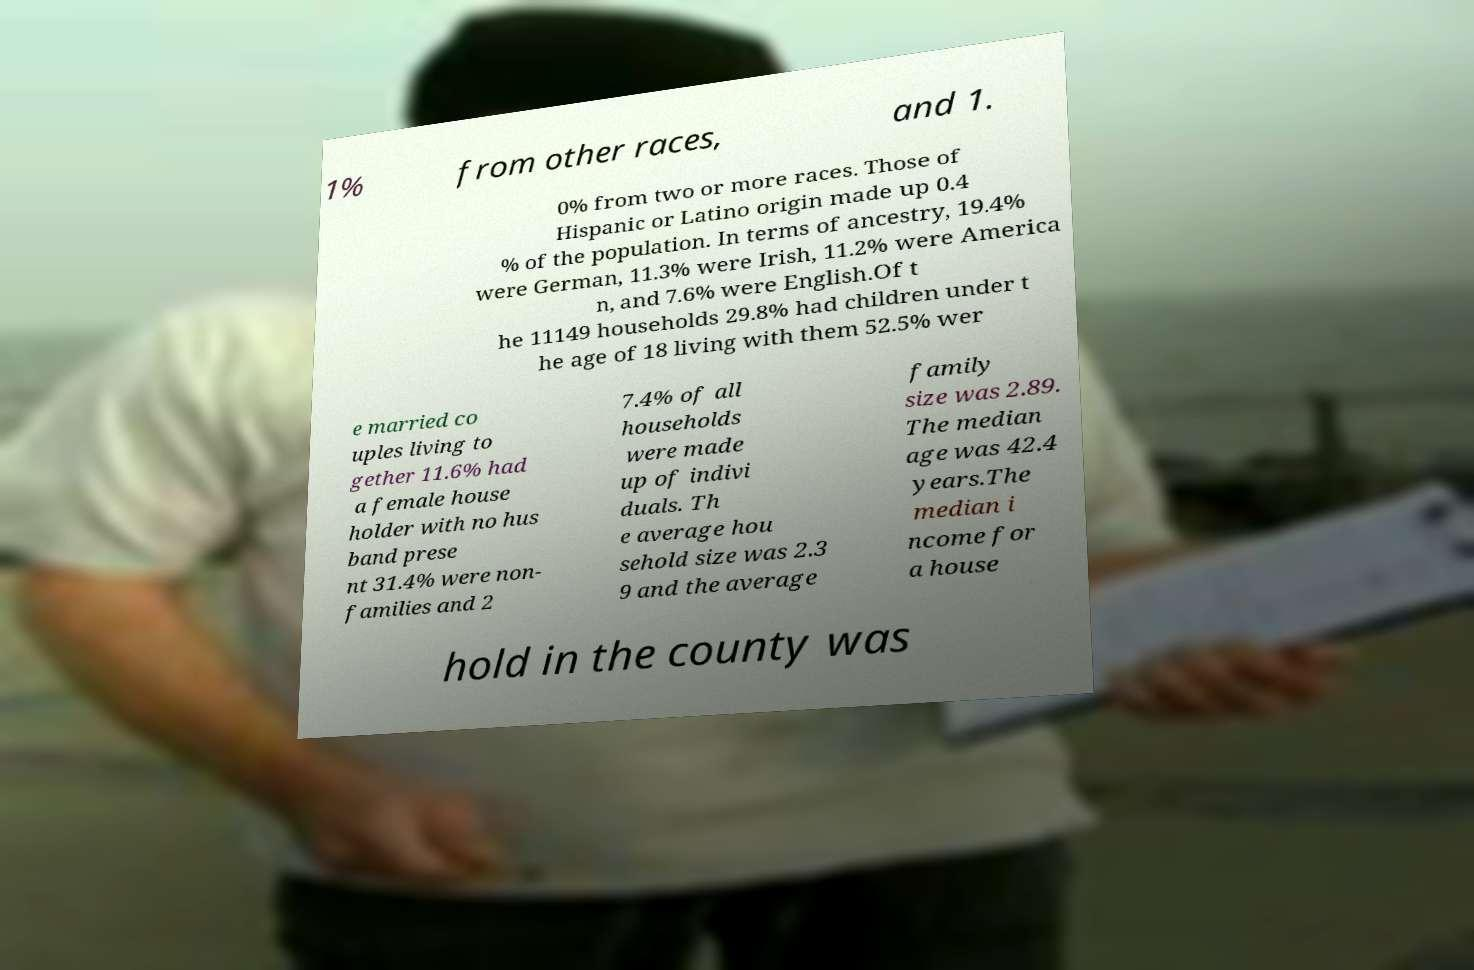For documentation purposes, I need the text within this image transcribed. Could you provide that? 1% from other races, and 1. 0% from two or more races. Those of Hispanic or Latino origin made up 0.4 % of the population. In terms of ancestry, 19.4% were German, 11.3% were Irish, 11.2% were America n, and 7.6% were English.Of t he 11149 households 29.8% had children under t he age of 18 living with them 52.5% wer e married co uples living to gether 11.6% had a female house holder with no hus band prese nt 31.4% were non- families and 2 7.4% of all households were made up of indivi duals. Th e average hou sehold size was 2.3 9 and the average family size was 2.89. The median age was 42.4 years.The median i ncome for a house hold in the county was 